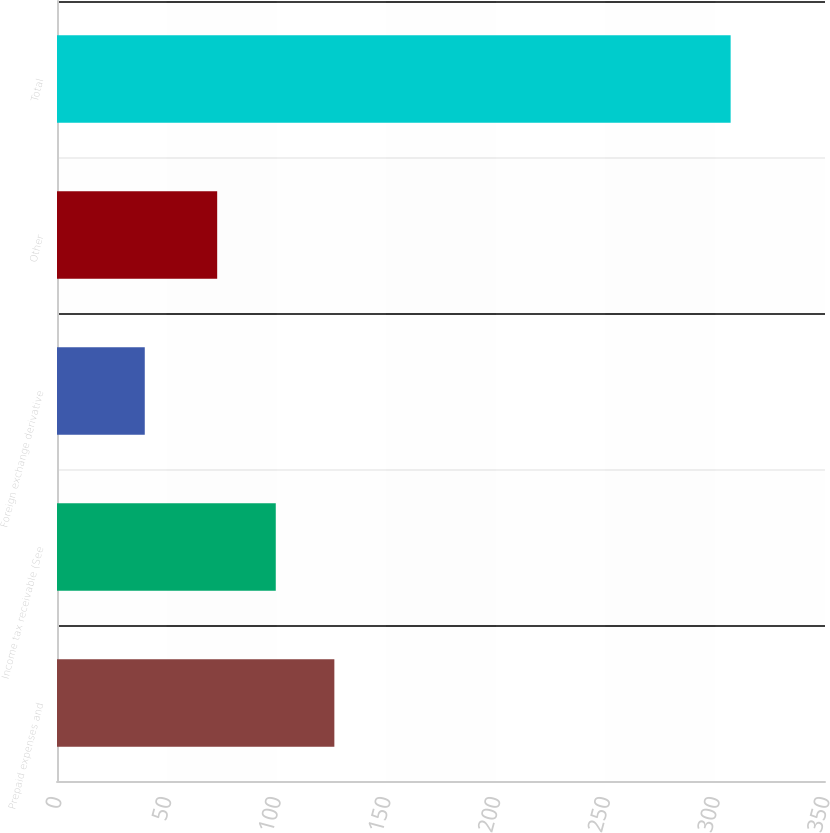<chart> <loc_0><loc_0><loc_500><loc_500><bar_chart><fcel>Prepaid expenses and<fcel>Income tax receivable (See<fcel>Foreign exchange derivative<fcel>Other<fcel>Total<nl><fcel>126.4<fcel>99.7<fcel>40<fcel>73<fcel>307<nl></chart> 